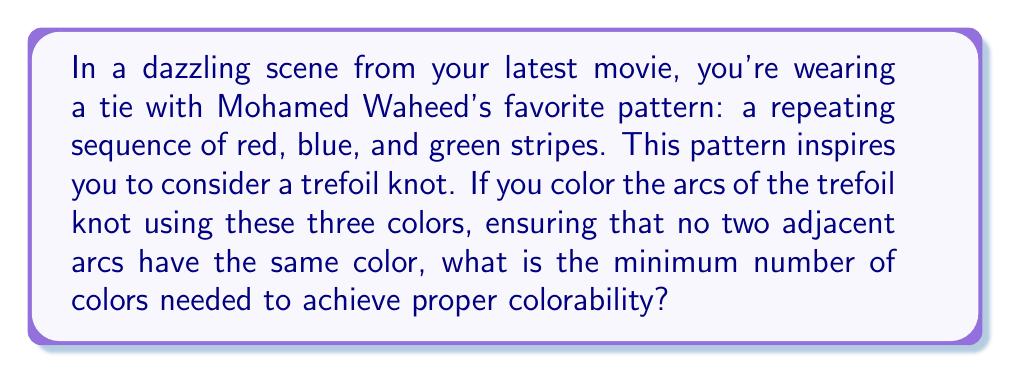Show me your answer to this math problem. Let's approach this step-by-step:

1) First, recall that a trefoil knot has three crossings and three arcs.

2) The colorability of a knot is determined by the number of colors needed to color its diagram such that at each crossing, either all three arcs have the same color or all three are different.

3) For the trefoil knot:
   
   [asy]
   import geometry;
   
   size(100);
   
   path p = (0,0)..(1,1)..(0,2)..(-1,1)..(0,0);
   path q = (-0.5,0.5)..(0.5,1.5)..(0.5,0.5)..(-0.5,1.5)..(-0.5,0.5);
   
   draw(p,blue+1);
   draw(q,red+1);
   
   dot((0,0));
   dot((0,2));
   dot((-1,1));
   dot((1,1));
   [/asy]

4) Let's try to color it with two colors:
   - If we start with one color for an arc, the next arc must be the other color.
   - But when we reach the third arc, it needs to be different from both the first and second arcs.
   - This is impossible with only two colors.

5) Now, let's try with three colors (red, blue, and green):
   - We can color one arc red, the next blue, and the third green.
   - At each crossing, all three colors will be present.

6) This satisfies the colorability condition, as at each crossing, all three arcs have different colors.

7) The number of colors used (3) matches the number of colors in Mohamed Waheed's favorite pattern on your tie.

Therefore, the minimum number of colors needed for proper colorability of the trefoil knot is 3.
Answer: 3 